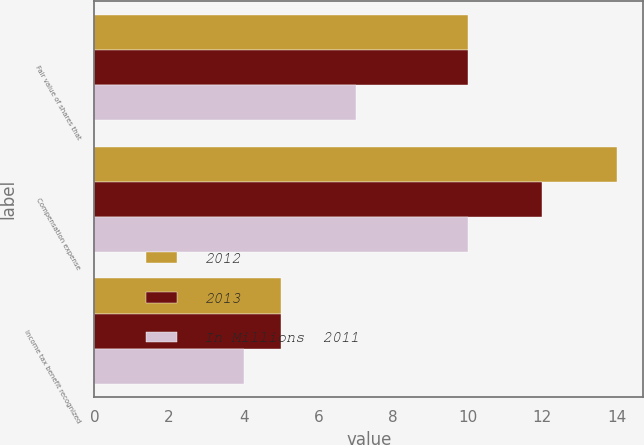Convert chart. <chart><loc_0><loc_0><loc_500><loc_500><stacked_bar_chart><ecel><fcel>Fair value of shares that<fcel>Compensation expense<fcel>Income tax benefit recognized<nl><fcel>2012<fcel>10<fcel>14<fcel>5<nl><fcel>2013<fcel>10<fcel>12<fcel>5<nl><fcel>In Millions  2011<fcel>7<fcel>10<fcel>4<nl></chart> 